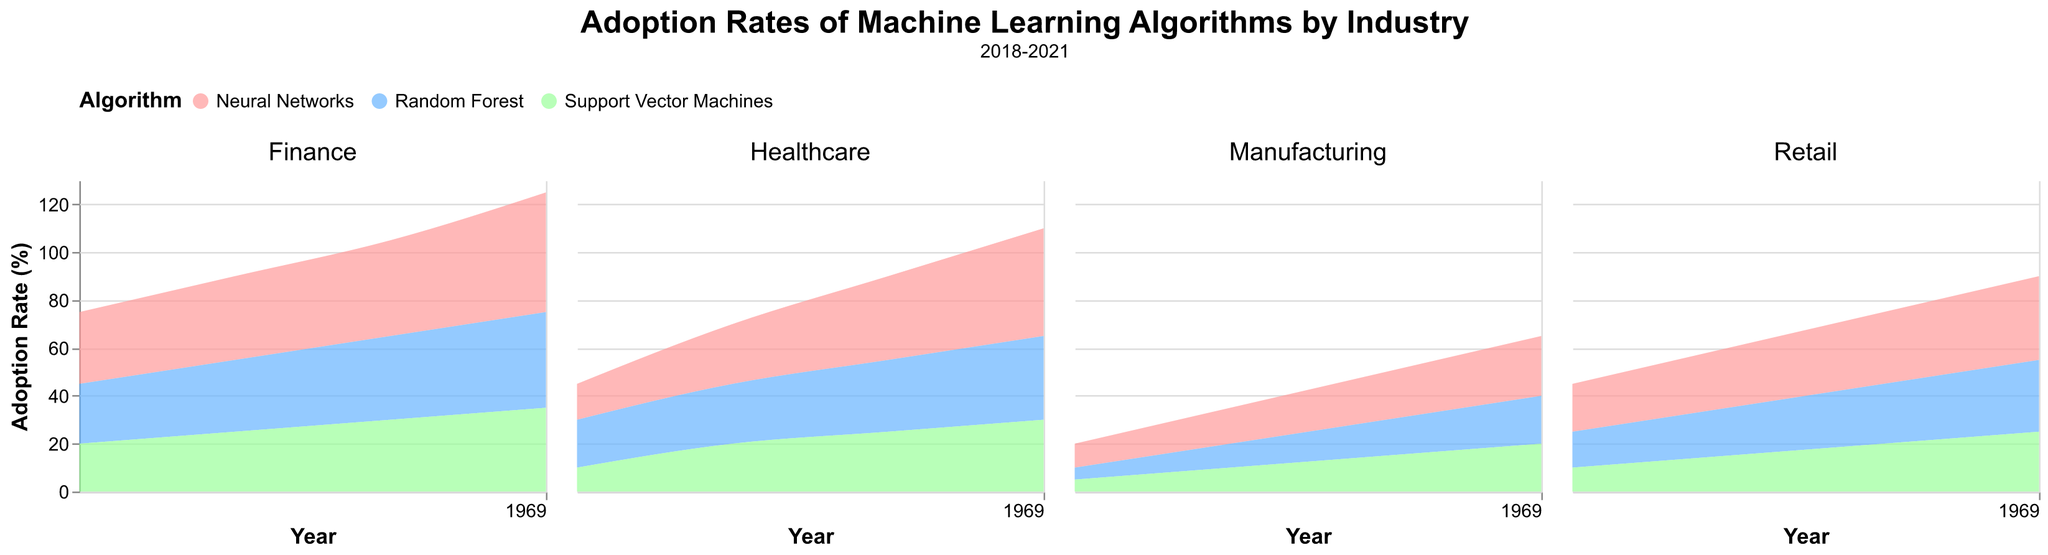Which industry had the highest adoption rate of Neural Networks in 2021? Observe the subplots and identify the highest point for Neural Networks in 2021. The Finance subplot shows the highest adoption rate, reaching 50%.
Answer: Finance How did the adoption rate of Random Forest in the Healthcare industry change from 2018 to 2021? Track the Random Forest adoption rate in the Healthcare subplot from 2018 to 2021, which rises steadily from 20% to 35%.
Answer: Increased from 20% to 35% Which algorithm saw the lowest adoption rate in the Manufacturing industry in 2018? In the Manufacturing subplot for 2018, both Random Forest and Support Vector Machines had the lowest adoption rate, which was 5%.
Answer: Random Forest and Support Vector Machines What was the overall trend in the adoption rate of Support Vector Machines in Retail from 2018 to 2021? Examine the Retail subplot's trend line for Support Vector Machines, which shows a consistent increase from 10% to 25%.
Answer: Increasing Compare the adoption rates of Neural Networks and Support Vector Machines in Finance in 2019. Which one was higher, and by how much? In the Finance subplot for 2019, Neural Networks had an adoption rate of 35%, and Support Vector Machines had 25%. The difference is 10%.
Answer: Neural Networks by 10% What is the average adoption rate of Random Forest across all industries in 2020? Calculate the average for Random Forest in 2020: Healthcare (30%), Finance (35%), Retail (25%), and Manufacturing (15%). Average = (30 + 35 + 25 + 15) / 4 = 26.25%
Answer: 26.25% Identify the industry with the smallest increase in the adoption rate of Neural Networks from 2018 to 2021. Compare the increase in Neural Networks adoption from 2018 to 2021 across all industries: Healthcare (30), Finance (20), Retail (15), Manufacturing (15). Manufacturing and Retail both had the smallest increase of 15%.
Answer: Manufacturing and Retail Which industry had the steadiest rise in the adoption rate of Support Vector Machines from 2018 to 2021? Examine the subplots for smooth, constant increases for Support Vector Machines. Healthcare subplot shows a steady increase every year from 10% to 30%.
Answer: Healthcare What is the difference in the adoption rate of Neural Networks between Healthcare and Manufacturing in 2020? Neural Networks adoption rate in Healthcare in 2020 was 35%, while in Manufacturing it was 20%. The difference is 15%.
Answer: 15% How did the adoption rates of all algorithms in Finance compare to one another in 2021? Look at the Finance subplot for 2021: Neural Networks reached 50%, Random Forest 40%, and Support Vector Machines 35%. Neural Networks had the highest rate, followed by Random Forest and then Support Vector Machines.
Answer: Neural Networks > Random Forest > Support Vector Machines 